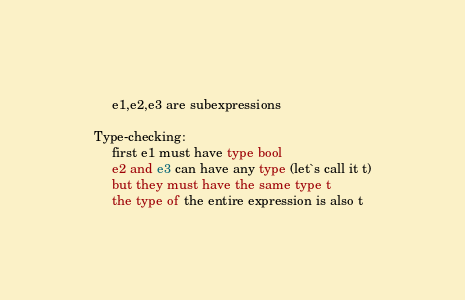Convert code to text. <code><loc_0><loc_0><loc_500><loc_500><_SML_>     e1,e2,e3 are subexpressions

Type-checking:
     first e1 must have type bool
     e2 and e3 can have any type (let`s call it t)
     but they must have the same type t
     the type of the entire expression is also t
</code> 